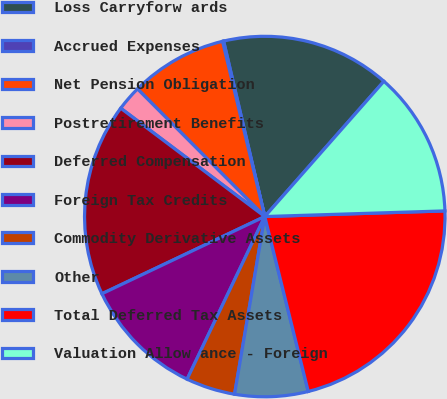Convert chart. <chart><loc_0><loc_0><loc_500><loc_500><pie_chart><fcel>Loss Carryforw ards<fcel>Accrued Expenses<fcel>Net Pension Obligation<fcel>Postretirement Benefits<fcel>Deferred Compensation<fcel>Foreign Tax Credits<fcel>Commodity Derivative Assets<fcel>Other<fcel>Total Deferred Tax Assets<fcel>Valuation Allow ance - Foreign<nl><fcel>15.16%<fcel>0.1%<fcel>8.71%<fcel>2.26%<fcel>17.31%<fcel>10.86%<fcel>4.41%<fcel>6.56%<fcel>21.62%<fcel>13.01%<nl></chart> 